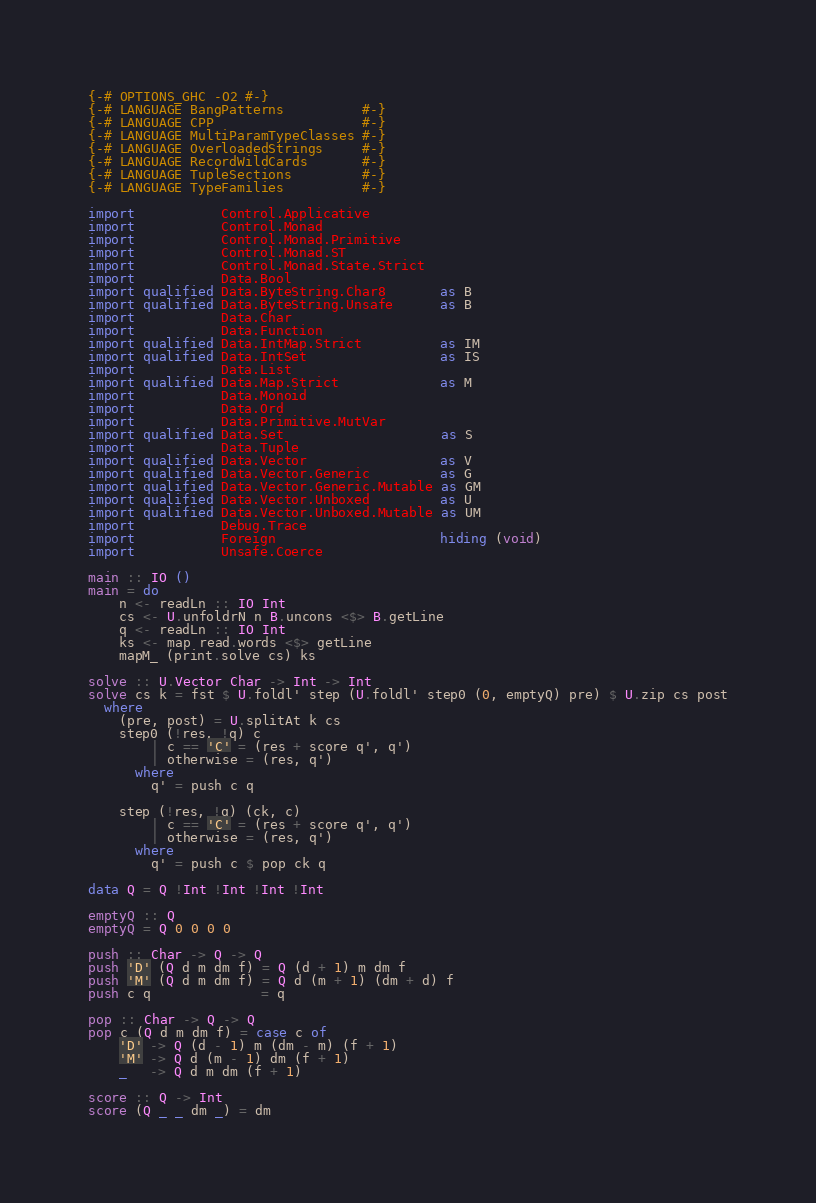Convert code to text. <code><loc_0><loc_0><loc_500><loc_500><_Haskell_>{-# OPTIONS_GHC -O2 #-}
{-# LANGUAGE BangPatterns          #-}
{-# LANGUAGE CPP                   #-}
{-# LANGUAGE MultiParamTypeClasses #-}
{-# LANGUAGE OverloadedStrings     #-}
{-# LANGUAGE RecordWildCards       #-}
{-# LANGUAGE TupleSections         #-}
{-# LANGUAGE TypeFamilies          #-}

import           Control.Applicative
import           Control.Monad
import           Control.Monad.Primitive
import           Control.Monad.ST
import           Control.Monad.State.Strict
import           Data.Bool
import qualified Data.ByteString.Char8       as B
import qualified Data.ByteString.Unsafe      as B
import           Data.Char
import           Data.Function
import qualified Data.IntMap.Strict          as IM
import qualified Data.IntSet                 as IS
import           Data.List
import qualified Data.Map.Strict             as M
import           Data.Monoid
import           Data.Ord
import           Data.Primitive.MutVar
import qualified Data.Set                    as S
import           Data.Tuple
import qualified Data.Vector                 as V
import qualified Data.Vector.Generic         as G
import qualified Data.Vector.Generic.Mutable as GM
import qualified Data.Vector.Unboxed         as U
import qualified Data.Vector.Unboxed.Mutable as UM
import           Debug.Trace
import           Foreign                     hiding (void)
import           Unsafe.Coerce

main :: IO ()
main = do
    n <- readLn :: IO Int
    cs <- U.unfoldrN n B.uncons <$> B.getLine
    q <- readLn :: IO Int
    ks <- map read.words <$> getLine
    mapM_ (print.solve cs) ks

solve :: U.Vector Char -> Int -> Int
solve cs k = fst $ U.foldl' step (U.foldl' step0 (0, emptyQ) pre) $ U.zip cs post
  where
    (pre, post) = U.splitAt k cs
    step0 (!res, !q) c
        | c == 'C' = (res + score q', q')
        | otherwise = (res, q')
      where
        q' = push c q

    step (!res, !q) (ck, c)
        | c == 'C' = (res + score q', q')
        | otherwise = (res, q')
      where
        q' = push c $ pop ck q

data Q = Q !Int !Int !Int !Int

emptyQ :: Q
emptyQ = Q 0 0 0 0

push :: Char -> Q -> Q
push 'D' (Q d m dm f) = Q (d + 1) m dm f
push 'M' (Q d m dm f) = Q d (m + 1) (dm + d) f
push c q              = q

pop :: Char -> Q -> Q
pop c (Q d m dm f) = case c of
    'D' -> Q (d - 1) m (dm - m) (f + 1)
    'M' -> Q d (m - 1) dm (f + 1)
    _   -> Q d m dm (f + 1)

score :: Q -> Int
score (Q _ _ dm _) = dm
</code> 